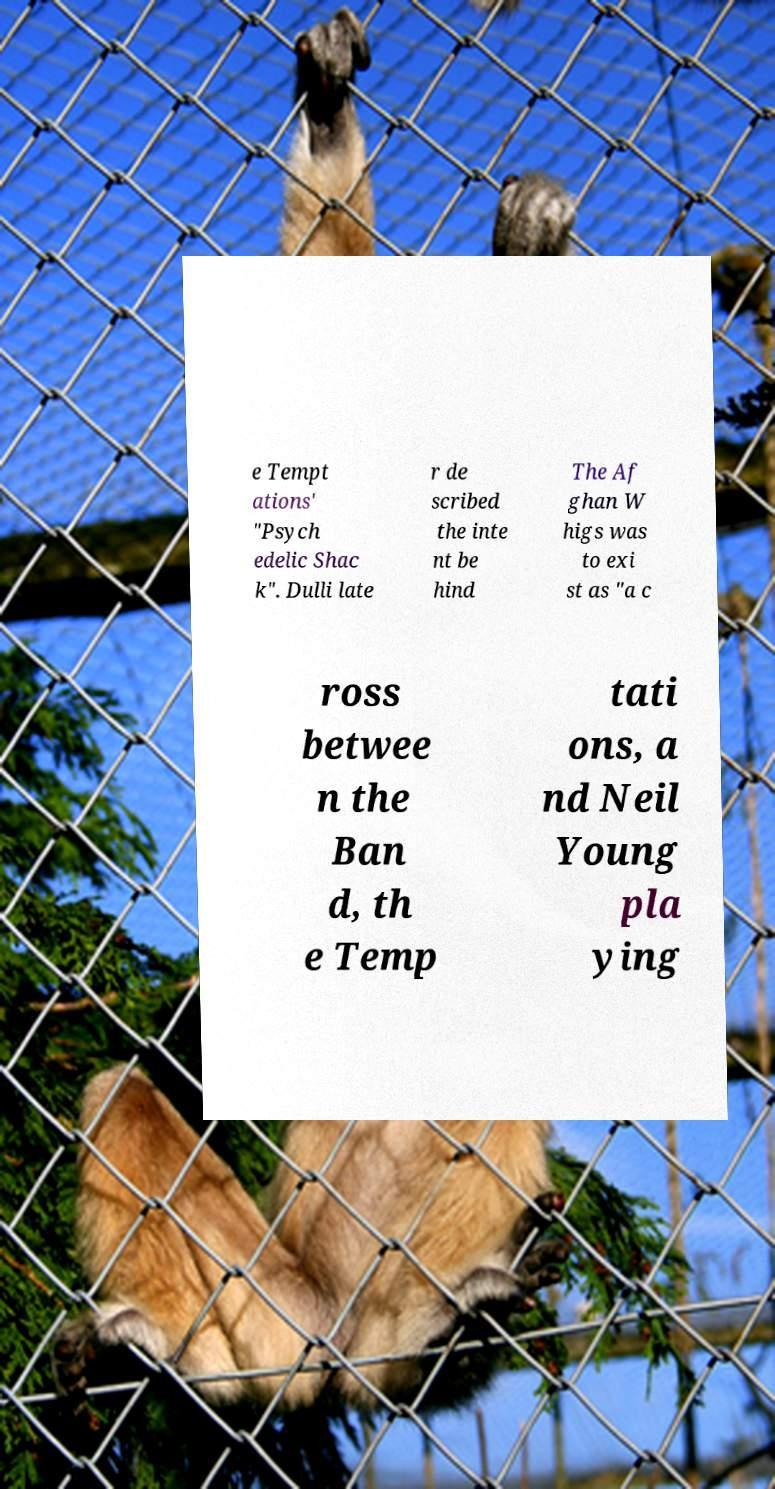I need the written content from this picture converted into text. Can you do that? e Tempt ations' "Psych edelic Shac k". Dulli late r de scribed the inte nt be hind The Af ghan W higs was to exi st as "a c ross betwee n the Ban d, th e Temp tati ons, a nd Neil Young pla ying 